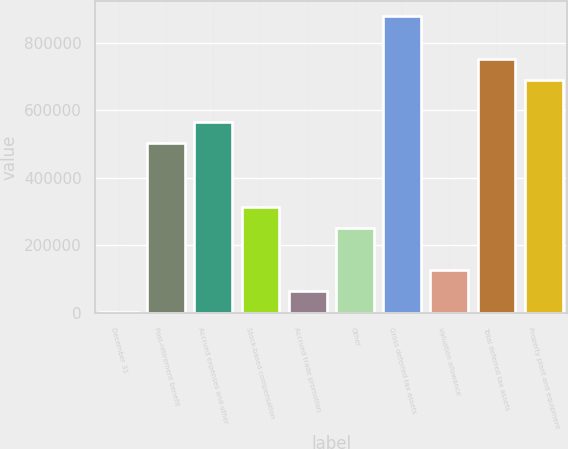<chart> <loc_0><loc_0><loc_500><loc_500><bar_chart><fcel>December 31<fcel>Post-retirement benefit<fcel>Accrued expenses and other<fcel>Stock-based compensation<fcel>Accrued trade promotion<fcel>Other<fcel>Gross deferred tax assets<fcel>Valuation allowance<fcel>Total deferred tax assets<fcel>Property plant and equipment<nl><fcel>2005<fcel>502466<fcel>565023<fcel>314793<fcel>64562.6<fcel>252235<fcel>877811<fcel>127120<fcel>752696<fcel>690139<nl></chart> 